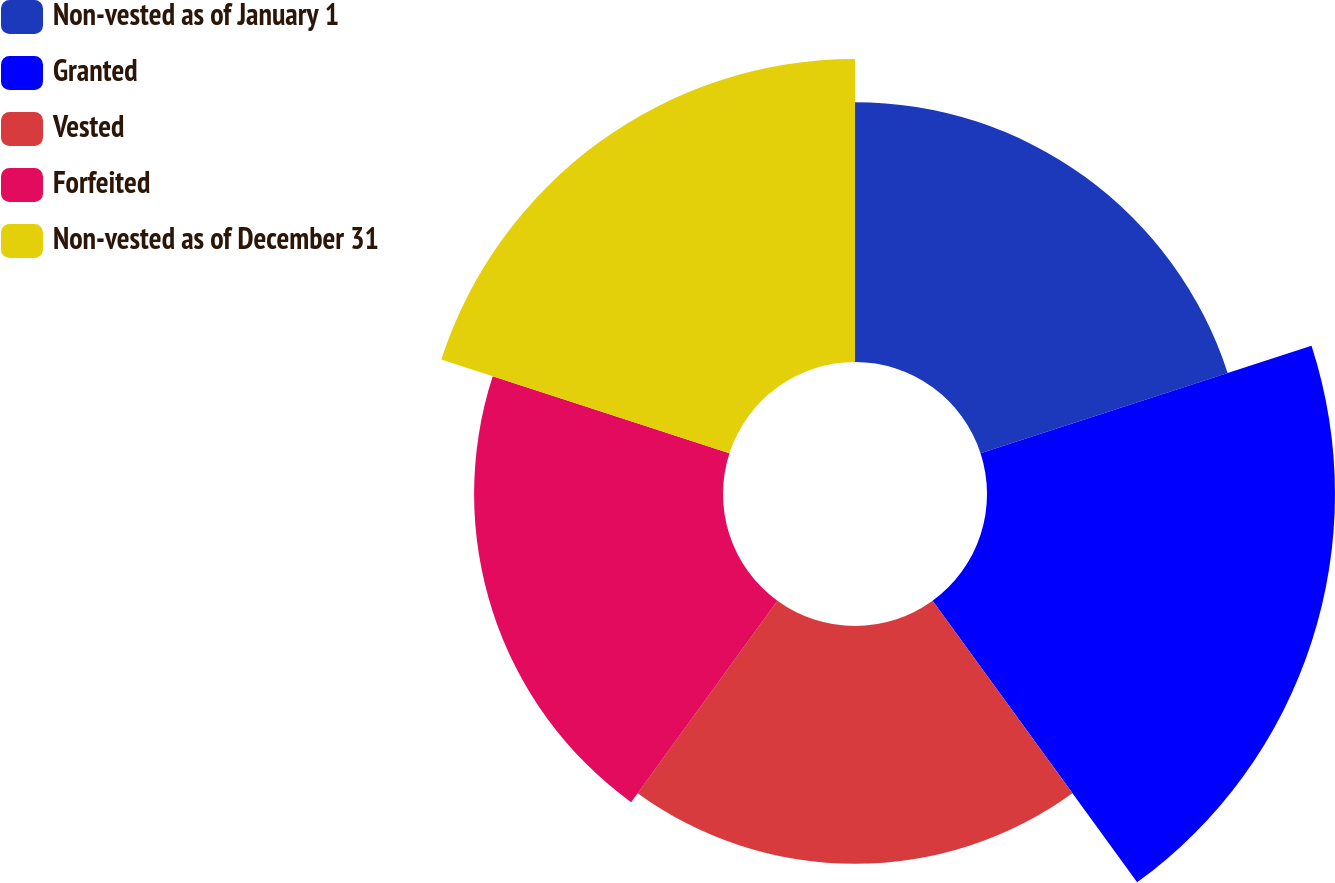Convert chart to OTSL. <chart><loc_0><loc_0><loc_500><loc_500><pie_chart><fcel>Non-vested as of January 1<fcel>Granted<fcel>Vested<fcel>Forfeited<fcel>Non-vested as of December 31<nl><fcel>18.59%<fcel>24.9%<fcel>17.02%<fcel>17.81%<fcel>21.68%<nl></chart> 